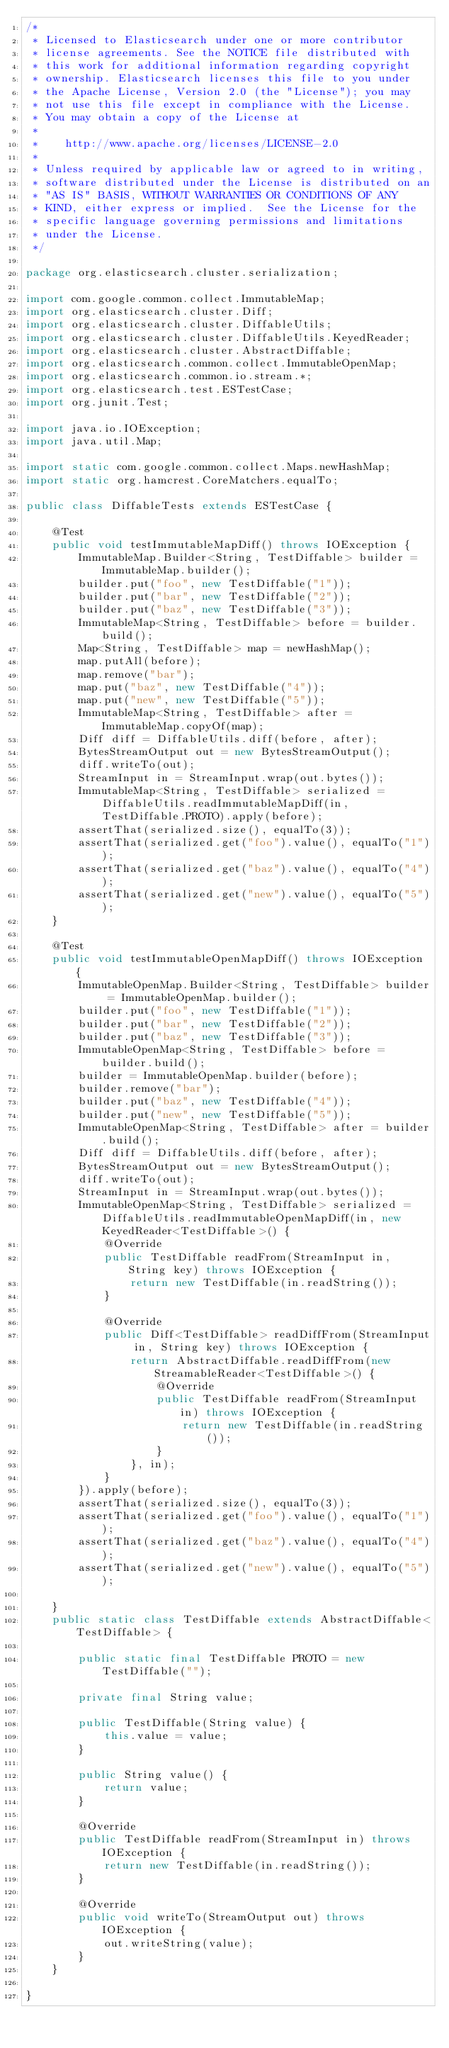Convert code to text. <code><loc_0><loc_0><loc_500><loc_500><_Java_>/*
 * Licensed to Elasticsearch under one or more contributor
 * license agreements. See the NOTICE file distributed with
 * this work for additional information regarding copyright
 * ownership. Elasticsearch licenses this file to you under
 * the Apache License, Version 2.0 (the "License"); you may
 * not use this file except in compliance with the License.
 * You may obtain a copy of the License at
 *
 *    http://www.apache.org/licenses/LICENSE-2.0
 *
 * Unless required by applicable law or agreed to in writing,
 * software distributed under the License is distributed on an
 * "AS IS" BASIS, WITHOUT WARRANTIES OR CONDITIONS OF ANY
 * KIND, either express or implied.  See the License for the
 * specific language governing permissions and limitations
 * under the License.
 */

package org.elasticsearch.cluster.serialization;

import com.google.common.collect.ImmutableMap;
import org.elasticsearch.cluster.Diff;
import org.elasticsearch.cluster.DiffableUtils;
import org.elasticsearch.cluster.DiffableUtils.KeyedReader;
import org.elasticsearch.cluster.AbstractDiffable;
import org.elasticsearch.common.collect.ImmutableOpenMap;
import org.elasticsearch.common.io.stream.*;
import org.elasticsearch.test.ESTestCase;
import org.junit.Test;

import java.io.IOException;
import java.util.Map;

import static com.google.common.collect.Maps.newHashMap;
import static org.hamcrest.CoreMatchers.equalTo;

public class DiffableTests extends ESTestCase {

    @Test
    public void testImmutableMapDiff() throws IOException {
        ImmutableMap.Builder<String, TestDiffable> builder = ImmutableMap.builder();
        builder.put("foo", new TestDiffable("1"));
        builder.put("bar", new TestDiffable("2"));
        builder.put("baz", new TestDiffable("3"));
        ImmutableMap<String, TestDiffable> before = builder.build();
        Map<String, TestDiffable> map = newHashMap();
        map.putAll(before);
        map.remove("bar");
        map.put("baz", new TestDiffable("4"));
        map.put("new", new TestDiffable("5"));
        ImmutableMap<String, TestDiffable> after = ImmutableMap.copyOf(map);
        Diff diff = DiffableUtils.diff(before, after);
        BytesStreamOutput out = new BytesStreamOutput();
        diff.writeTo(out);
        StreamInput in = StreamInput.wrap(out.bytes());
        ImmutableMap<String, TestDiffable> serialized = DiffableUtils.readImmutableMapDiff(in, TestDiffable.PROTO).apply(before);
        assertThat(serialized.size(), equalTo(3));
        assertThat(serialized.get("foo").value(), equalTo("1"));
        assertThat(serialized.get("baz").value(), equalTo("4"));
        assertThat(serialized.get("new").value(), equalTo("5"));
    }

    @Test
    public void testImmutableOpenMapDiff() throws IOException {
        ImmutableOpenMap.Builder<String, TestDiffable> builder = ImmutableOpenMap.builder();
        builder.put("foo", new TestDiffable("1"));
        builder.put("bar", new TestDiffable("2"));
        builder.put("baz", new TestDiffable("3"));
        ImmutableOpenMap<String, TestDiffable> before = builder.build();
        builder = ImmutableOpenMap.builder(before);
        builder.remove("bar");
        builder.put("baz", new TestDiffable("4"));
        builder.put("new", new TestDiffable("5"));
        ImmutableOpenMap<String, TestDiffable> after = builder.build();
        Diff diff = DiffableUtils.diff(before, after);
        BytesStreamOutput out = new BytesStreamOutput();
        diff.writeTo(out);
        StreamInput in = StreamInput.wrap(out.bytes());
        ImmutableOpenMap<String, TestDiffable> serialized = DiffableUtils.readImmutableOpenMapDiff(in, new KeyedReader<TestDiffable>() {
            @Override
            public TestDiffable readFrom(StreamInput in, String key) throws IOException {
                return new TestDiffable(in.readString());
            }

            @Override
            public Diff<TestDiffable> readDiffFrom(StreamInput in, String key) throws IOException {
                return AbstractDiffable.readDiffFrom(new StreamableReader<TestDiffable>() {
                    @Override
                    public TestDiffable readFrom(StreamInput in) throws IOException {
                        return new TestDiffable(in.readString());
                    }
                }, in);
            }
        }).apply(before);
        assertThat(serialized.size(), equalTo(3));
        assertThat(serialized.get("foo").value(), equalTo("1"));
        assertThat(serialized.get("baz").value(), equalTo("4"));
        assertThat(serialized.get("new").value(), equalTo("5"));

    }
    public static class TestDiffable extends AbstractDiffable<TestDiffable> {

        public static final TestDiffable PROTO = new TestDiffable("");

        private final String value;

        public TestDiffable(String value) {
            this.value = value;
        }

        public String value() {
            return value;
        }

        @Override
        public TestDiffable readFrom(StreamInput in) throws IOException {
            return new TestDiffable(in.readString());
        }

        @Override
        public void writeTo(StreamOutput out) throws IOException {
            out.writeString(value);
        }
    }

}
</code> 